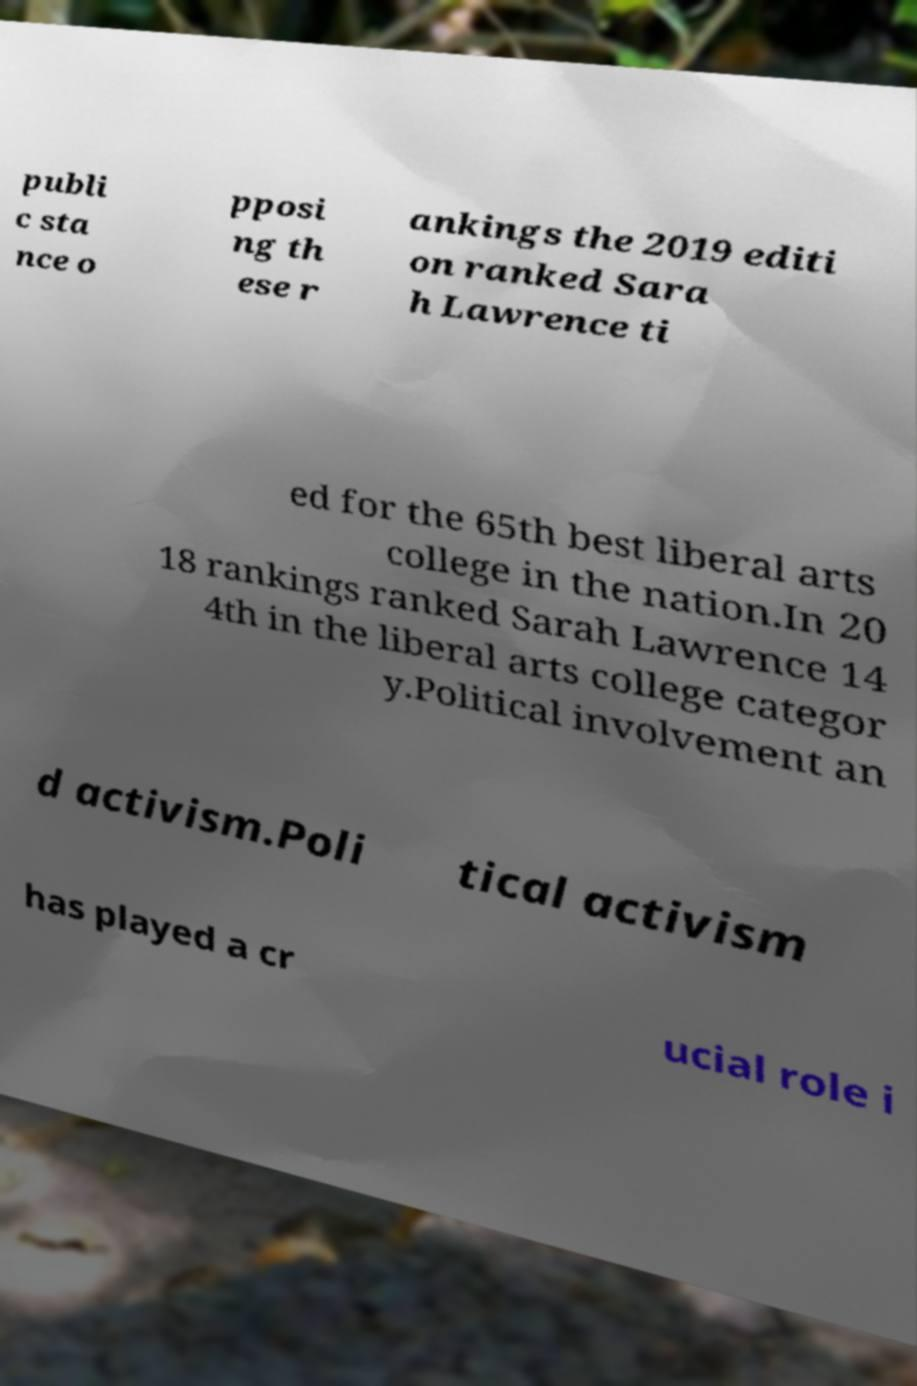There's text embedded in this image that I need extracted. Can you transcribe it verbatim? publi c sta nce o pposi ng th ese r ankings the 2019 editi on ranked Sara h Lawrence ti ed for the 65th best liberal arts college in the nation.In 20 18 rankings ranked Sarah Lawrence 14 4th in the liberal arts college categor y.Political involvement an d activism.Poli tical activism has played a cr ucial role i 